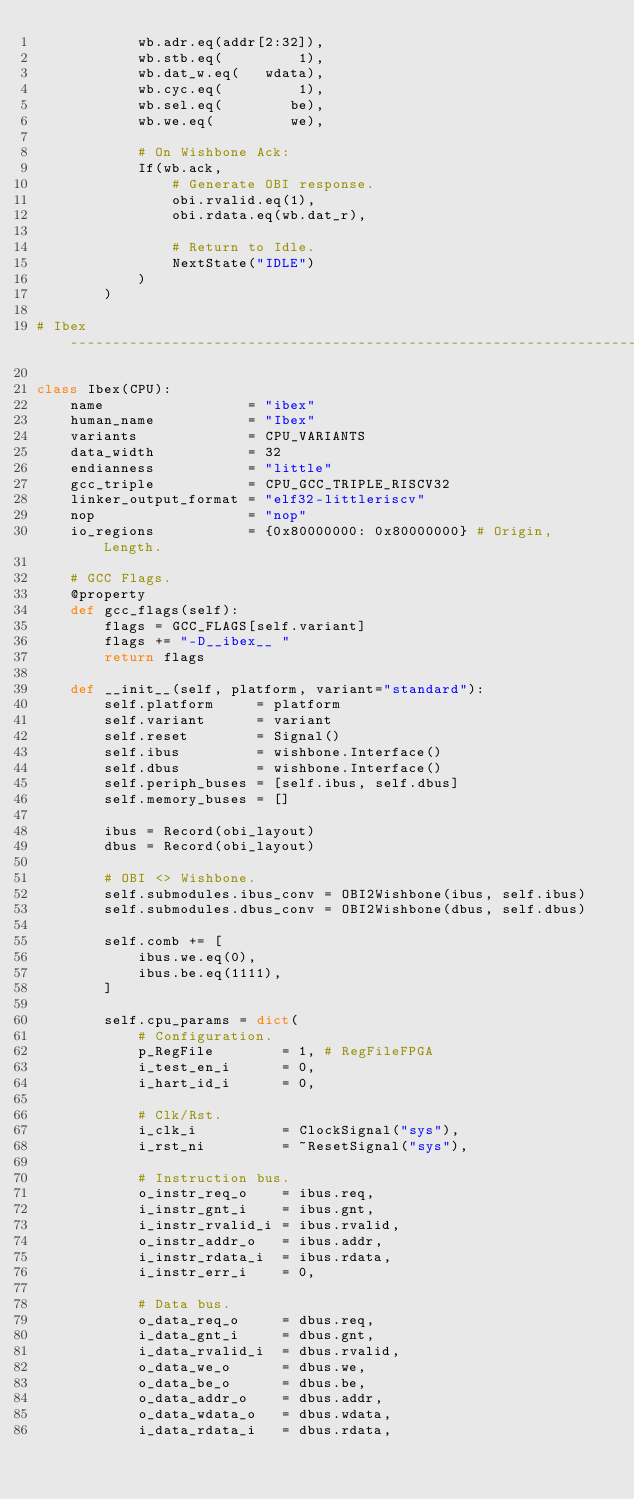<code> <loc_0><loc_0><loc_500><loc_500><_Python_>            wb.adr.eq(addr[2:32]),
            wb.stb.eq(         1),
            wb.dat_w.eq(   wdata),
            wb.cyc.eq(         1),
            wb.sel.eq(        be),
            wb.we.eq(         we),

            # On Wishbone Ack:
            If(wb.ack,
                # Generate OBI response.
                obi.rvalid.eq(1),
                obi.rdata.eq(wb.dat_r),

                # Return to Idle.
                NextState("IDLE")
            )
        )

# Ibex ---------------------------------------------------------------------------------------------

class Ibex(CPU):
    name                 = "ibex"
    human_name           = "Ibex"
    variants             = CPU_VARIANTS
    data_width           = 32
    endianness           = "little"
    gcc_triple           = CPU_GCC_TRIPLE_RISCV32
    linker_output_format = "elf32-littleriscv"
    nop                  = "nop"
    io_regions           = {0x80000000: 0x80000000} # Origin, Length.

    # GCC Flags.
    @property
    def gcc_flags(self):
        flags = GCC_FLAGS[self.variant]
        flags += "-D__ibex__ "
        return flags

    def __init__(self, platform, variant="standard"):
        self.platform     = platform
        self.variant      = variant
        self.reset        = Signal()
        self.ibus         = wishbone.Interface()
        self.dbus         = wishbone.Interface()
        self.periph_buses = [self.ibus, self.dbus]
        self.memory_buses = []

        ibus = Record(obi_layout)
        dbus = Record(obi_layout)

        # OBI <> Wishbone.
        self.submodules.ibus_conv = OBI2Wishbone(ibus, self.ibus)
        self.submodules.dbus_conv = OBI2Wishbone(dbus, self.dbus)

        self.comb += [
            ibus.we.eq(0),
            ibus.be.eq(1111),
        ]

        self.cpu_params = dict(
            # Configuration.
            p_RegFile        = 1, # RegFileFPGA
            i_test_en_i      = 0,
            i_hart_id_i      = 0,

            # Clk/Rst.
            i_clk_i          = ClockSignal("sys"),
            i_rst_ni         = ~ResetSignal("sys"),

            # Instruction bus.
            o_instr_req_o    = ibus.req,
            i_instr_gnt_i    = ibus.gnt,
            i_instr_rvalid_i = ibus.rvalid,
            o_instr_addr_o   = ibus.addr,
            i_instr_rdata_i  = ibus.rdata,
            i_instr_err_i    = 0,

            # Data bus.
            o_data_req_o     = dbus.req,
            i_data_gnt_i     = dbus.gnt,
            i_data_rvalid_i  = dbus.rvalid,
            o_data_we_o      = dbus.we,
            o_data_be_o      = dbus.be,
            o_data_addr_o    = dbus.addr,
            o_data_wdata_o   = dbus.wdata,
            i_data_rdata_i   = dbus.rdata,</code> 